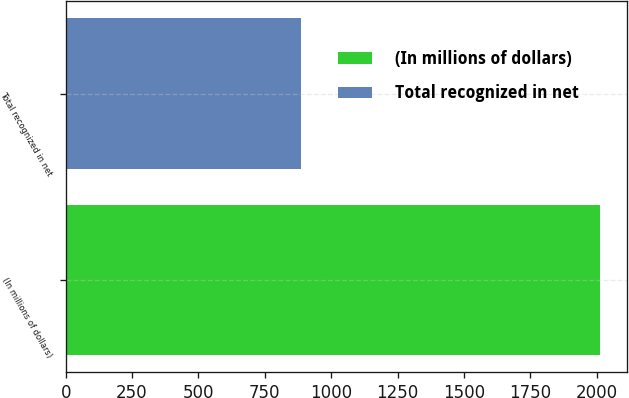<chart> <loc_0><loc_0><loc_500><loc_500><bar_chart><fcel>(In millions of dollars)<fcel>Total recognized in net<nl><fcel>2014<fcel>885<nl></chart> 